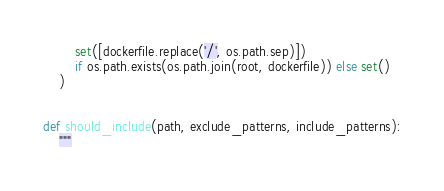Convert code to text. <code><loc_0><loc_0><loc_500><loc_500><_Python_>        set([dockerfile.replace('/', os.path.sep)])
        if os.path.exists(os.path.join(root, dockerfile)) else set()
    )


def should_include(path, exclude_patterns, include_patterns):
    """</code> 